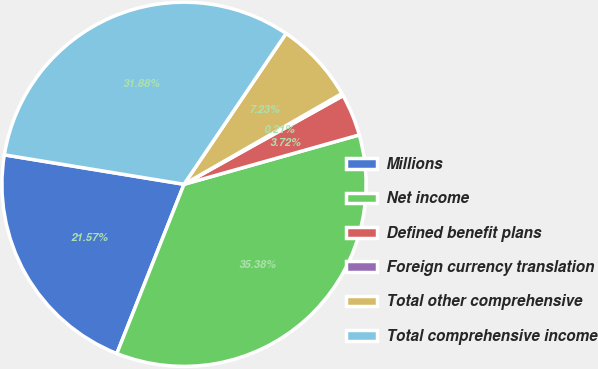Convert chart to OTSL. <chart><loc_0><loc_0><loc_500><loc_500><pie_chart><fcel>Millions<fcel>Net income<fcel>Defined benefit plans<fcel>Foreign currency translation<fcel>Total other comprehensive<fcel>Total comprehensive income<nl><fcel>21.57%<fcel>35.38%<fcel>3.72%<fcel>0.21%<fcel>7.23%<fcel>31.88%<nl></chart> 